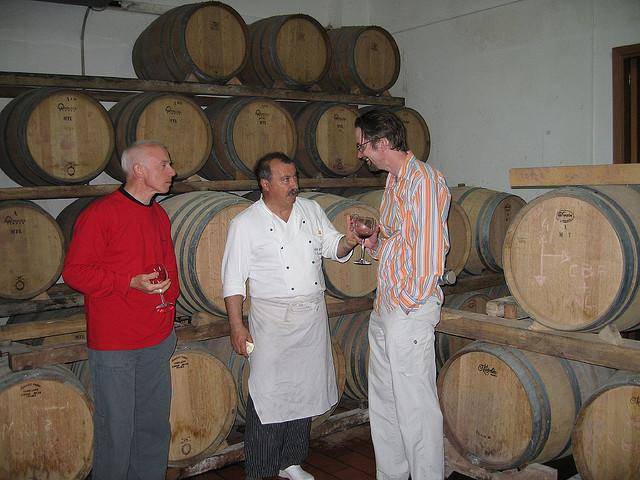What is contained inside the brown barrels?

Choices:
A) soy sauce
B) water
C) beer
D) wine wine 